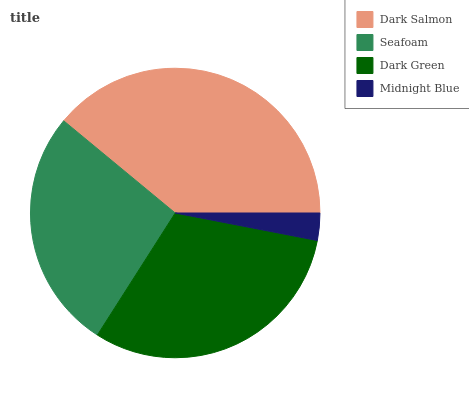Is Midnight Blue the minimum?
Answer yes or no. Yes. Is Dark Salmon the maximum?
Answer yes or no. Yes. Is Seafoam the minimum?
Answer yes or no. No. Is Seafoam the maximum?
Answer yes or no. No. Is Dark Salmon greater than Seafoam?
Answer yes or no. Yes. Is Seafoam less than Dark Salmon?
Answer yes or no. Yes. Is Seafoam greater than Dark Salmon?
Answer yes or no. No. Is Dark Salmon less than Seafoam?
Answer yes or no. No. Is Dark Green the high median?
Answer yes or no. Yes. Is Seafoam the low median?
Answer yes or no. Yes. Is Dark Salmon the high median?
Answer yes or no. No. Is Midnight Blue the low median?
Answer yes or no. No. 